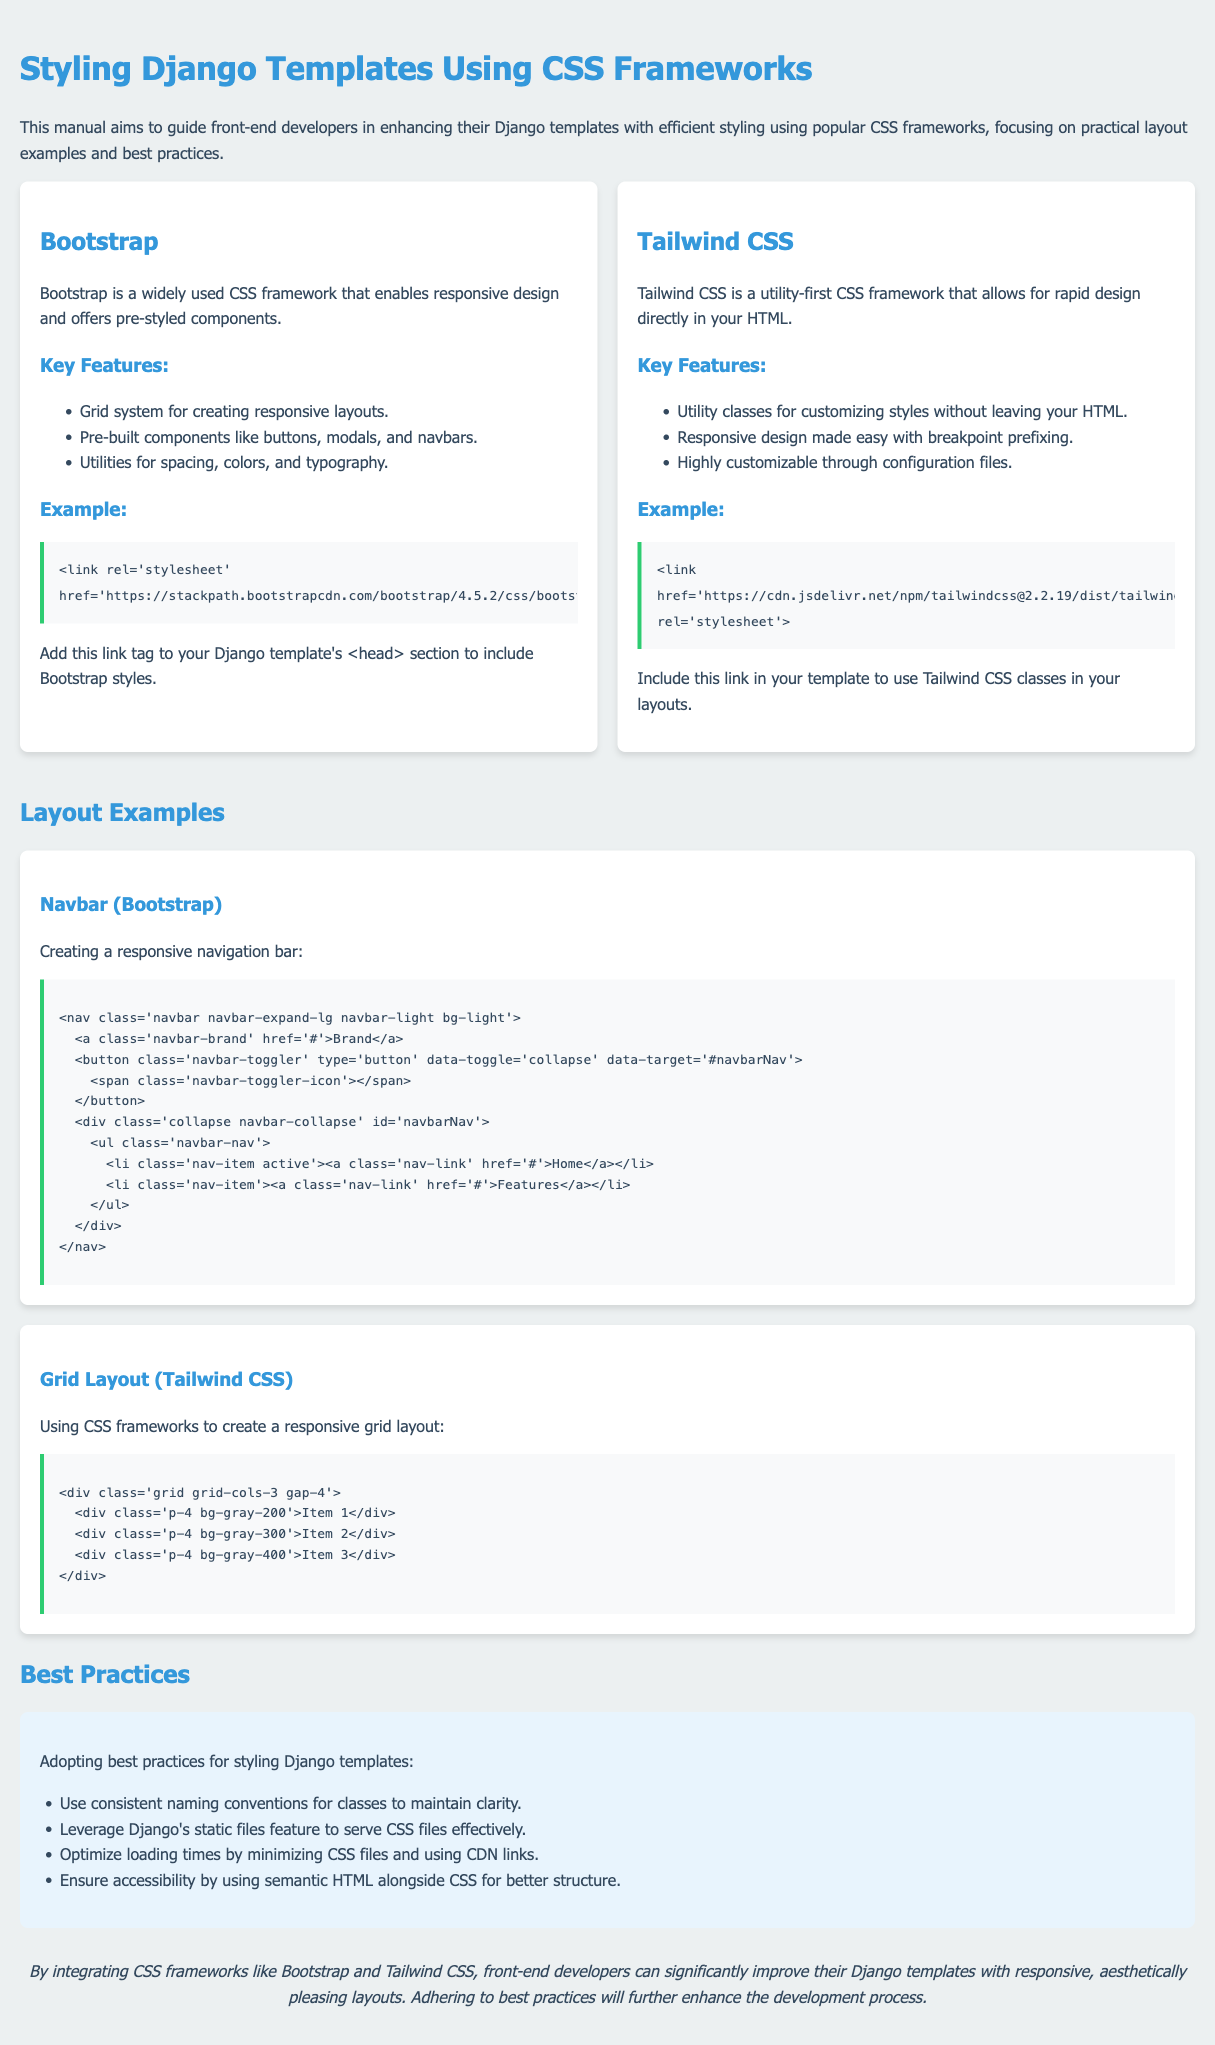what is the title of the document? The title is specified in the head section of the HTML and gives an overview of the content.
Answer: Styling Django Templates Using CSS Frameworks what is the primary color used in the styles? The primary color is defined as a variable and is used throughout the document for headings.
Answer: #3498db which CSS framework is mentioned first in the document? The order of appearance of the frameworks provides insight into which is highlighted first.
Answer: Bootstrap how many key features does Bootstrap have? The document lists specific features of Bootstrap, providing a count of items under this section.
Answer: Three what layout example is provided for Bootstrap? The specific layout example is mentioned with relation to a particular framework's usage.
Answer: Navbar how is the grid layout created using Tailwind CSS? The document describes the composition of a grid while utilizing Tailwind CSS's utility classes.
Answer: Responsive grid layout what is one of the best practices for styling Django templates? Several best practices are listed in the document, which contributes to a guide for developers.
Answer: Use consistent naming conventions where should you place the Bootstrap link in a Django template? The document describes the location in the HTML structure for including CSS frameworks.
Answer: Head section 